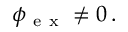Convert formula to latex. <formula><loc_0><loc_0><loc_500><loc_500>\boldsymbol _ { e x } \neq 0 \, .</formula> 